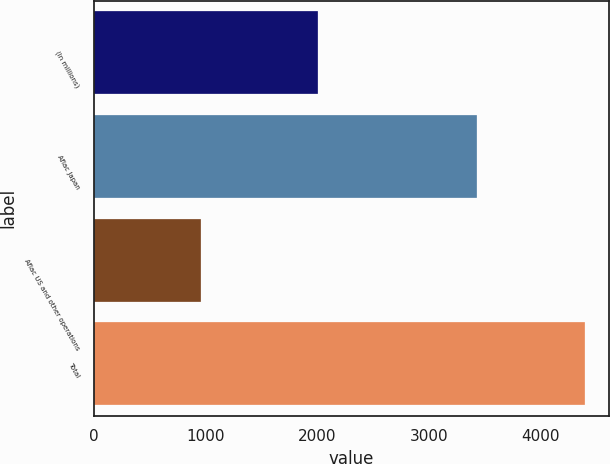Convert chart to OTSL. <chart><loc_0><loc_0><loc_500><loc_500><bar_chart><fcel>(In millions)<fcel>Aflac Japan<fcel>Aflac US and other operations<fcel>Total<nl><fcel>2006<fcel>3437<fcel>960<fcel>4397<nl></chart> 